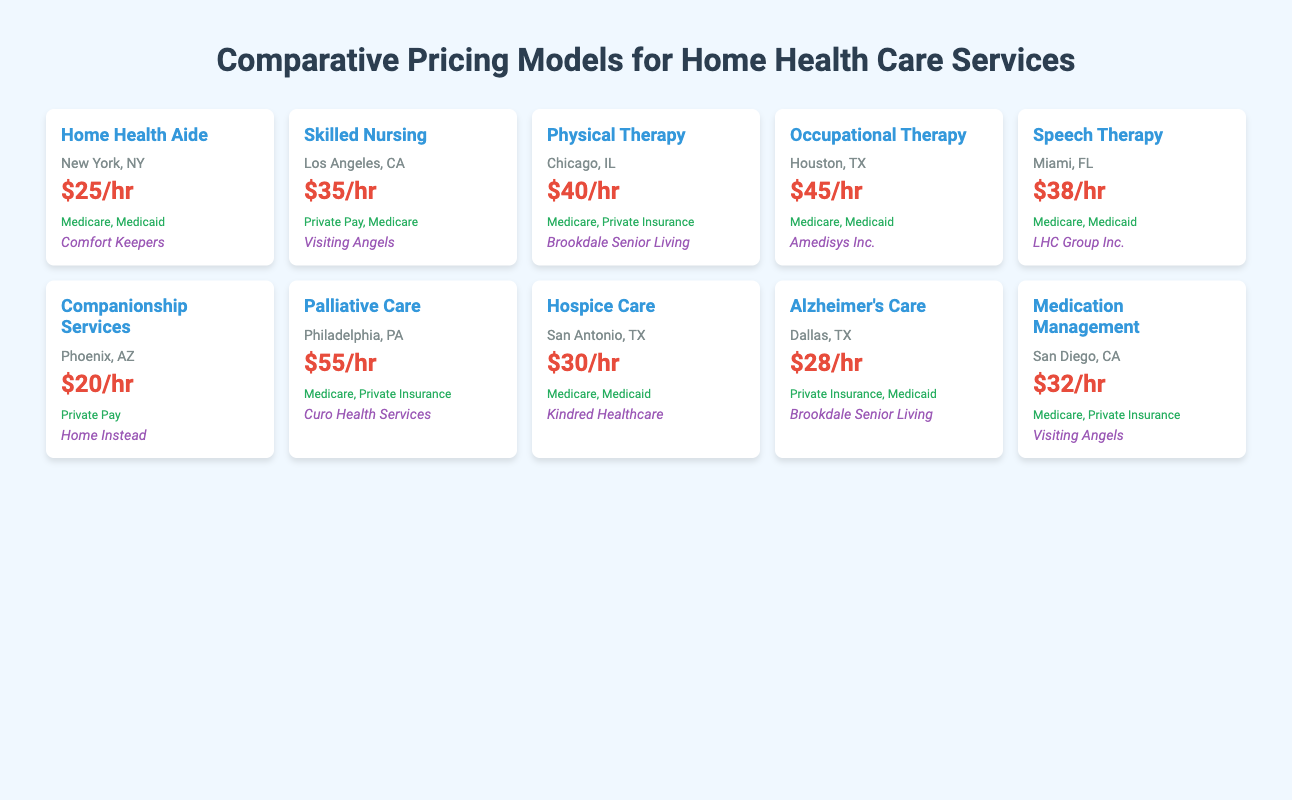What is the average hourly rate for Home Health Aide services in New York? The average hourly rate for Home Health Aide services in New York, NY is directly provided in the table as $25/hr.
Answer: $25/hr Which service has the highest average hourly rate and what is that rate? The service with the highest average hourly rate listed in the table is Palliative Care at $55/hr. This is identified by comparing all the average hourly rates in the table.
Answer: $55/hr (Palliative Care) Is it true that Physical Therapy services are covered by Private Insurance? According to the table, Physical Therapy services in Chicago, IL are covered by Medicare and Private Insurance, but are not specifically mentioned as covered only by Private Insurance. Therefore, the statement is false.
Answer: No How many services in the table have average hourly rates above $30? In the table, the services with an average hourly rate above $30 are Skilled Nursing ($35/hr), Physical Therapy ($40/hr), Occupational Therapy ($45/hr), Speech Therapy ($38/hr), Palliative Care ($55/hr), and Medication Management ($32/hr). This totals to six services.
Answer: 6 What is the difference between the average hourly rate of Occupational Therapy and Companionship Services? The average hourly rate for Occupational Therapy is $45/hr and for Companionship Services it is $20/hr. The difference is calculated as $45 - $20 = $25.
Answer: $25 Which service in Phoenix, AZ has the lowest hourly rate, and what is that rate? The service in Phoenix, AZ is Companionship Services with an hourly rate of $20/hr, which is the lowest in the table when comparing all services.
Answer: $20/hr (Companionship Services) Are there any services that have the same average hourly rate in different markets? Yes, both Hospice Care in San Antonio, TX and Home Health Aide in New York, NY have an average hourly rate of $30/hr. This can be confirmed by checking the average hourly rates for both services.
Answer: Yes What percentage of the services listed have insurance coverage from Medicare? Out of the ten services, one service (Companionship Services) does not have Medicare coverage. The remaining nine services have Medicare coverage. Therefore, the percentage is calculated as (9/10) * 100 = 90%.
Answer: 90% 